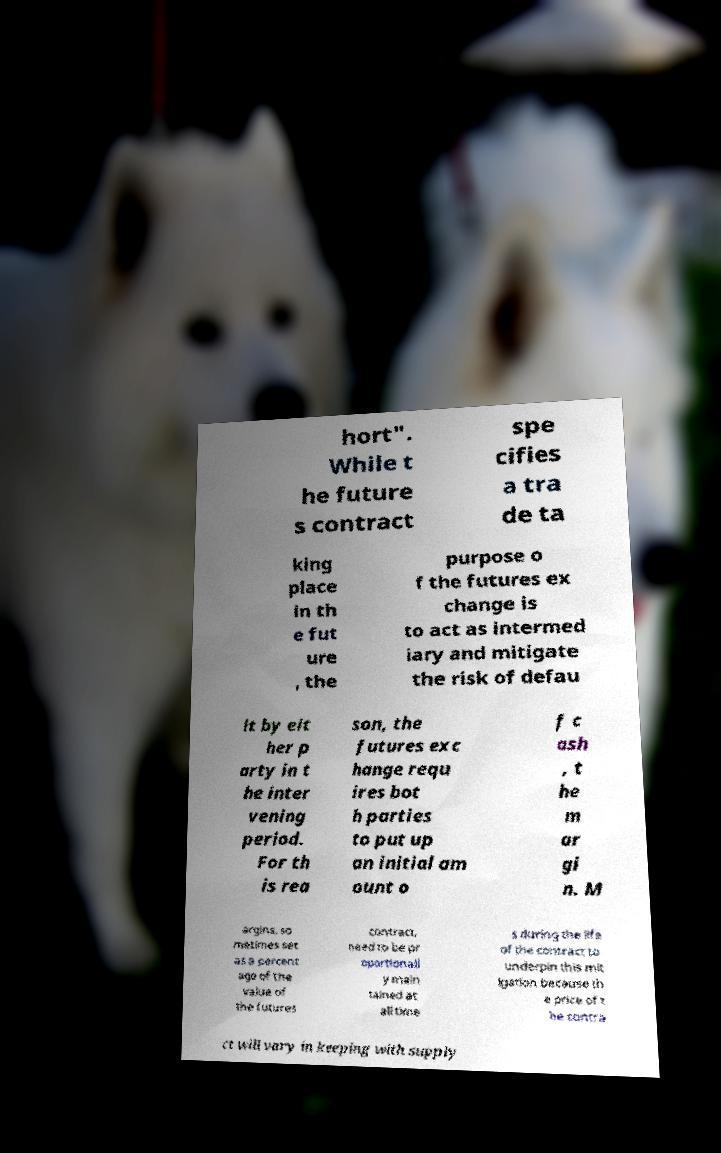Please read and relay the text visible in this image. What does it say? hort". While t he future s contract spe cifies a tra de ta king place in th e fut ure , the purpose o f the futures ex change is to act as intermed iary and mitigate the risk of defau lt by eit her p arty in t he inter vening period. For th is rea son, the futures exc hange requ ires bot h parties to put up an initial am ount o f c ash , t he m ar gi n. M argins, so metimes set as a percent age of the value of the futures contract, need to be pr oportionall y main tained at all time s during the life of the contract to underpin this mit igation because th e price of t he contra ct will vary in keeping with supply 